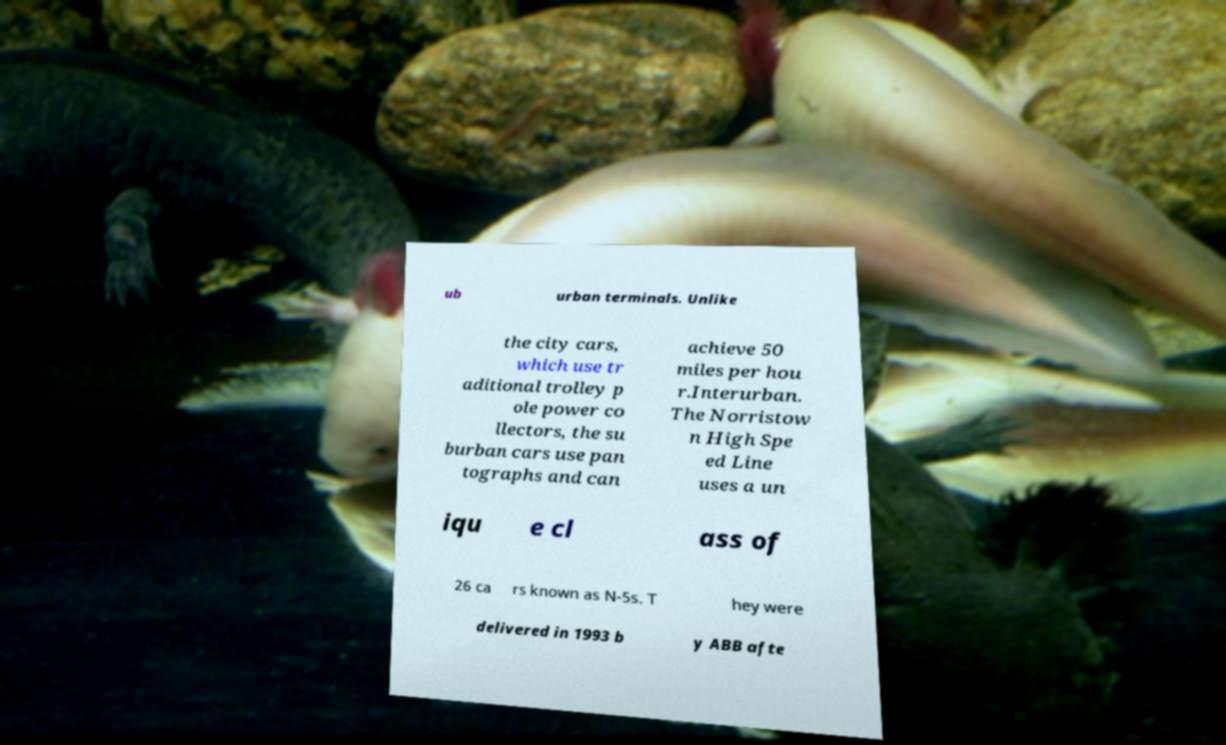Please read and relay the text visible in this image. What does it say? ub urban terminals. Unlike the city cars, which use tr aditional trolley p ole power co llectors, the su burban cars use pan tographs and can achieve 50 miles per hou r.Interurban. The Norristow n High Spe ed Line uses a un iqu e cl ass of 26 ca rs known as N-5s. T hey were delivered in 1993 b y ABB afte 